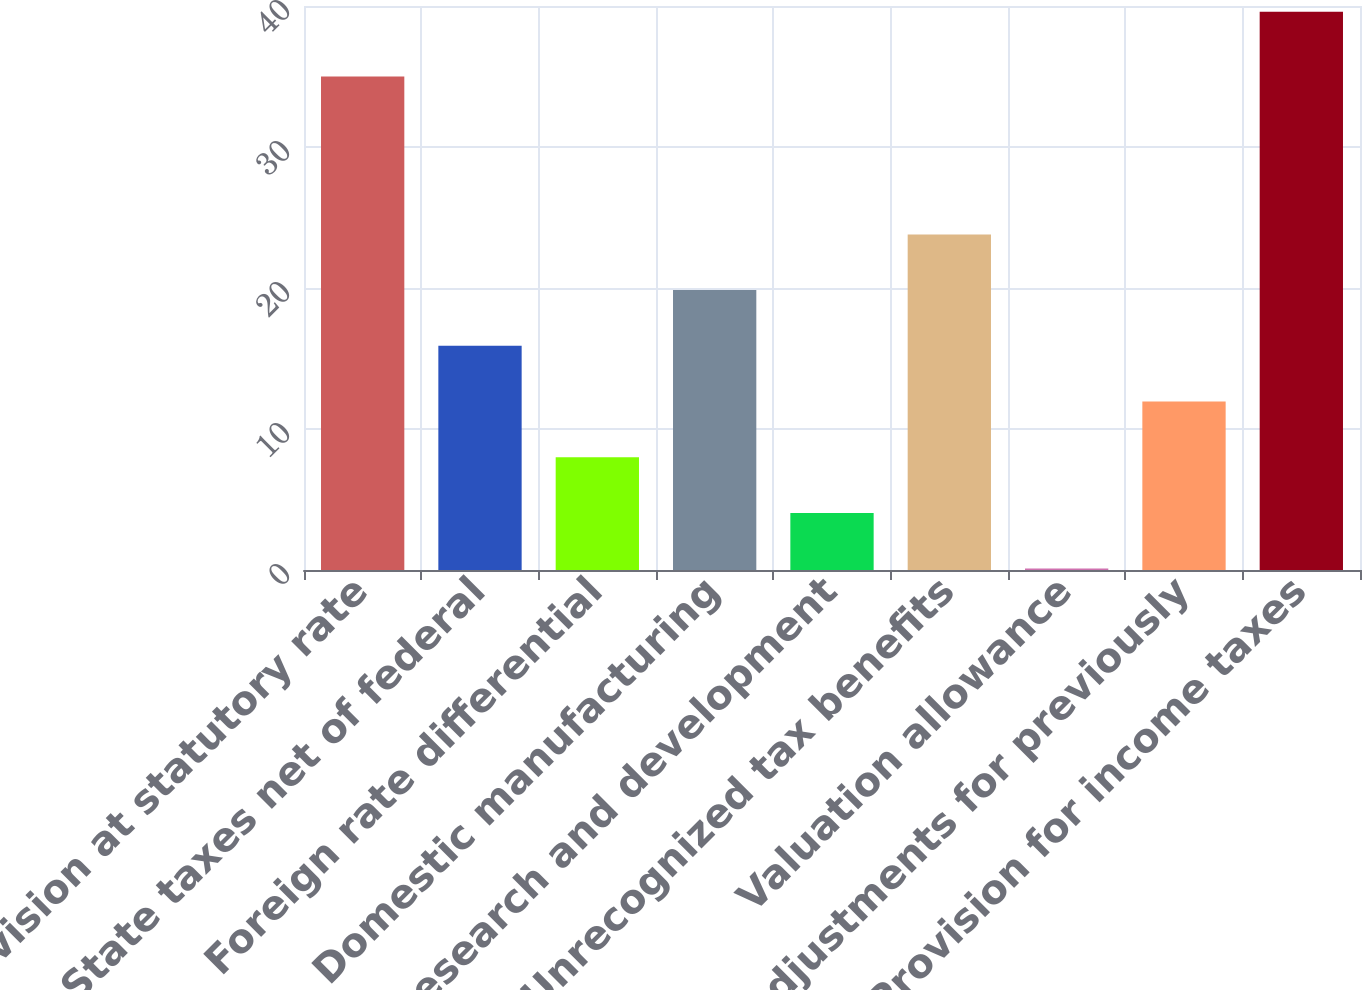Convert chart. <chart><loc_0><loc_0><loc_500><loc_500><bar_chart><fcel>Provision at statutory rate<fcel>State taxes net of federal<fcel>Foreign rate differential<fcel>Domestic manufacturing<fcel>Research and development<fcel>Unrecognized tax benefits<fcel>Valuation allowance<fcel>Adjustments for previously<fcel>Provision for income taxes<nl><fcel>35<fcel>15.9<fcel>8<fcel>19.85<fcel>4.05<fcel>23.8<fcel>0.1<fcel>11.95<fcel>39.6<nl></chart> 